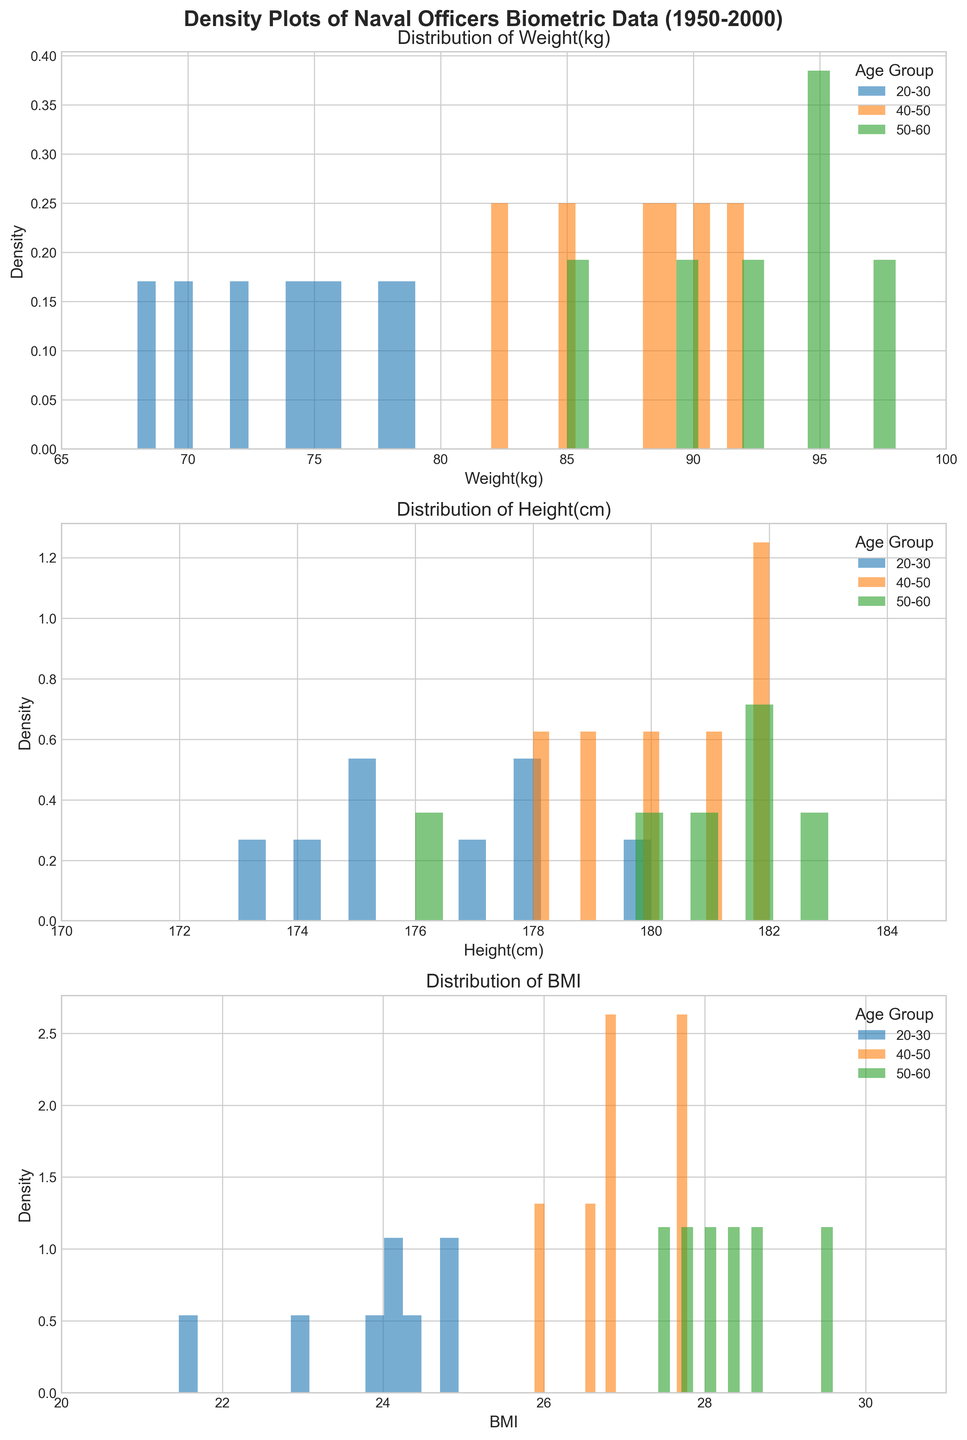What's the title of the figure? The title is displayed at the top of the figure, providing a concise description of the figure's content. The title is 'Density Plots of Naval Officers Biometric Data (1950-2000)'.
Answer: Density Plots of Naval Officers Biometric Data (1950-2000) Which metric shows the densest distribution between 70 and 80 kg for the age group 20-30? Looking at the distribution of 'Weight(kg)' for the age group 20-30, the density plot shows the highest peaks between 70 and 80 kg, indicating the concentration of data points in that range.
Answer: Weight(kg) What is the color used to represent the 50-60 age group? The legend on each subplot indicates the colors corresponding to each age group. The color used for the 50-60 age group is green.
Answer: Green Which age group shows the widest range of heights? By comparing the distribution of 'Height(cm)' for each age group, the age group 50-60 has the widest spread compared to the other age groups, covering more of the x-axis range.
Answer: 50-60 For BMI, which age group shows a distribution that peaks around 26? Observing the distribution of the 'BMI' subplot, the age group 40-50 shows a density peak around the value of 26.
Answer: 40-50 Do any of the age groups have overlapping distributions for weight? Yes, the distributions for the weight of the age groups 20-30, 40-50, and 50-60 overlap, especially in the range from 70 to 90 kg.
Answer: Yes What is the approximate range of BMI values for the 20-30 age group? Looking at the density plot for 'BMI' in the 20-30 age group, the distribution appears concentrated approximately between 22 and 25.
Answer: 22-25 Which age group has the highest peak for weight above 90 kg? In the weight subplot, the age group 50-60 shows a peak extending above 90 kg, indicating a higher concentration of weight in this range.
Answer: 50-60 How are the axes labeled in the subplots? Each subplot has the x-axis labeled with the respective metric ('Weight(kg)', 'Height(cm)', 'BMI'), and the y-axis labeled as 'Density'.
Answer: X-axis: respective metric, Y-axis: Density 